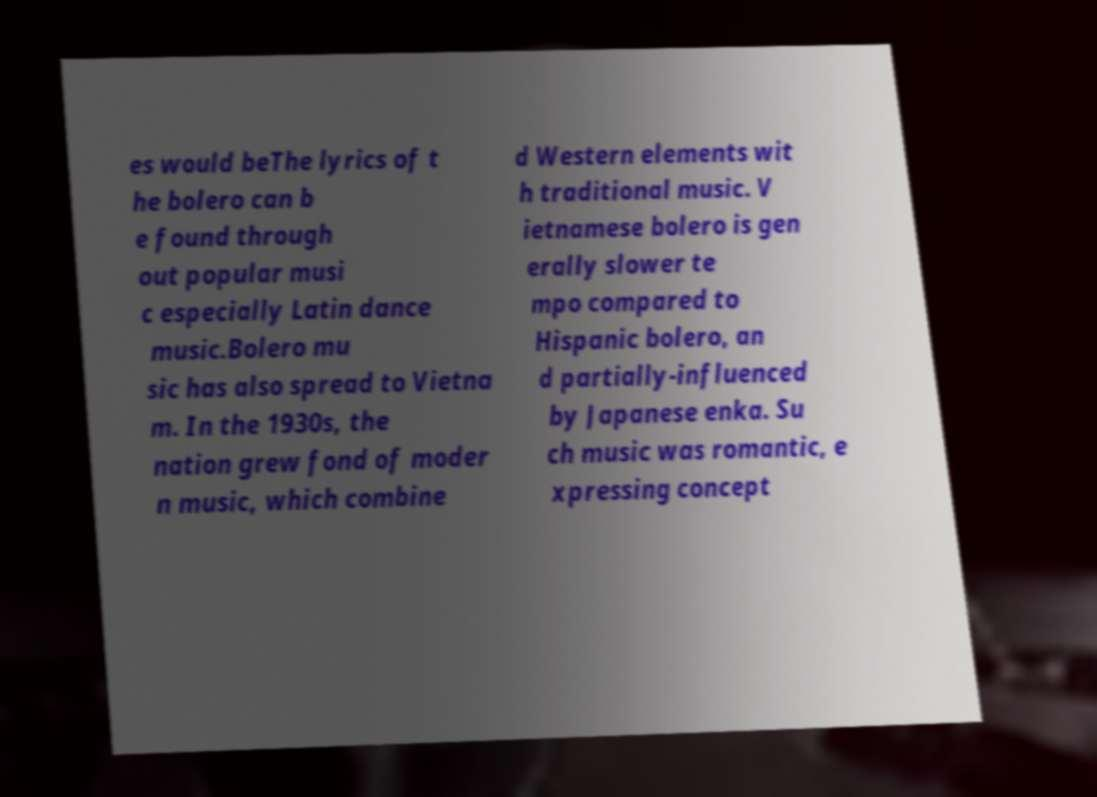Could you assist in decoding the text presented in this image and type it out clearly? es would beThe lyrics of t he bolero can b e found through out popular musi c especially Latin dance music.Bolero mu sic has also spread to Vietna m. In the 1930s, the nation grew fond of moder n music, which combine d Western elements wit h traditional music. V ietnamese bolero is gen erally slower te mpo compared to Hispanic bolero, an d partially-influenced by Japanese enka. Su ch music was romantic, e xpressing concept 